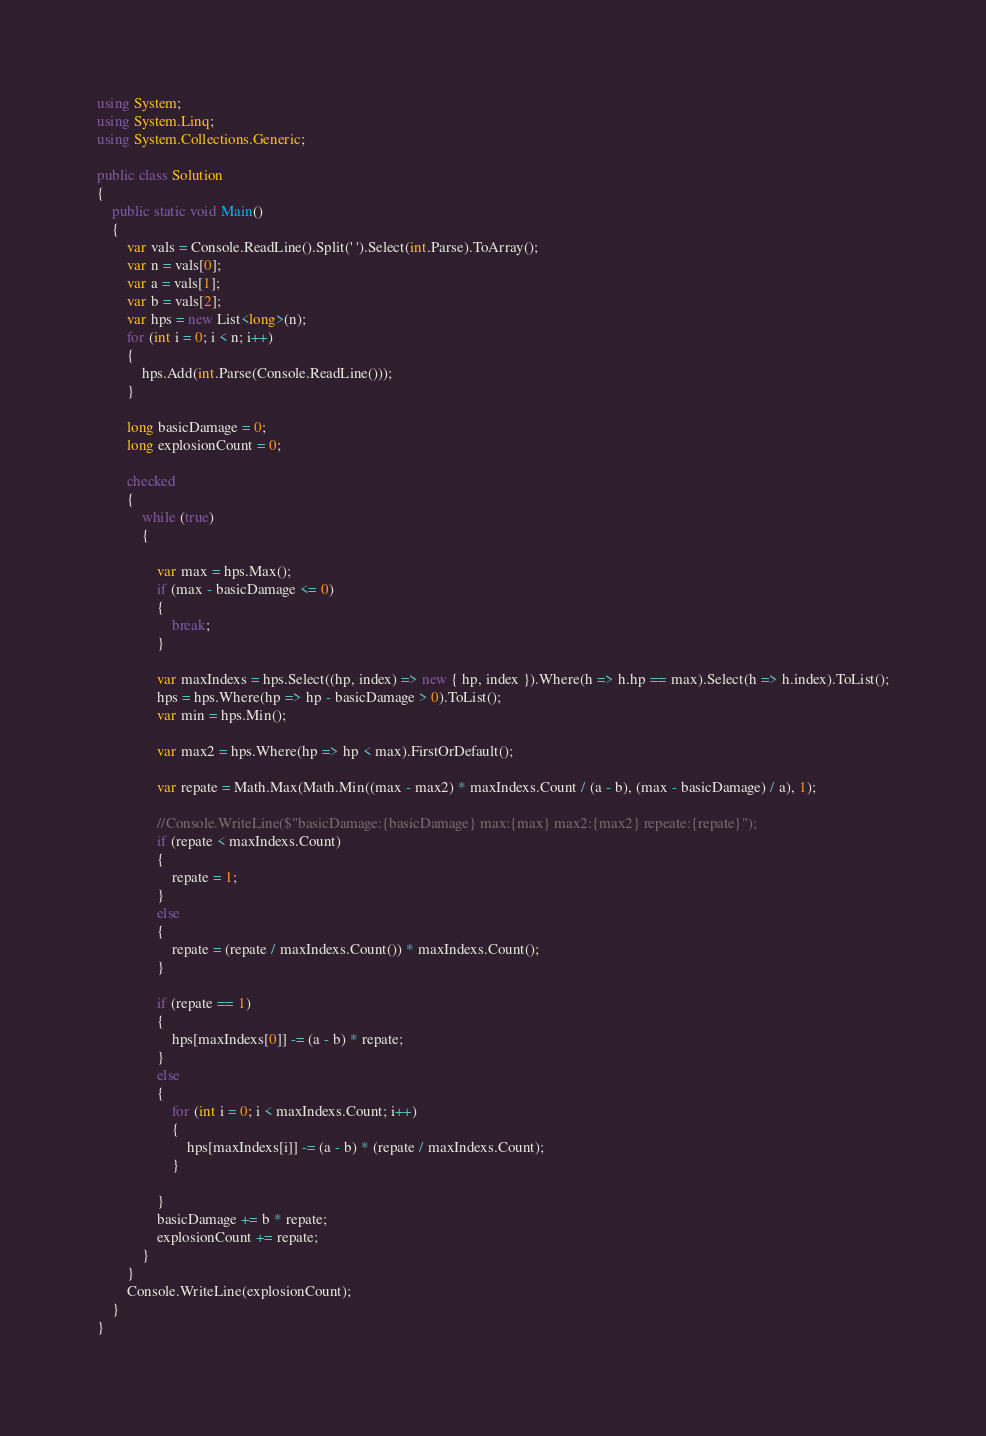Convert code to text. <code><loc_0><loc_0><loc_500><loc_500><_C#_>using System;
using System.Linq;
using System.Collections.Generic;

public class Solution
{
    public static void Main()
    {
        var vals = Console.ReadLine().Split(' ').Select(int.Parse).ToArray();
        var n = vals[0];
        var a = vals[1];
        var b = vals[2];
        var hps = new List<long>(n);
        for (int i = 0; i < n; i++)
        {
            hps.Add(int.Parse(Console.ReadLine()));
        }

        long basicDamage = 0;
        long explosionCount = 0;

        checked
        {
            while (true)
            {

                var max = hps.Max();
                if (max - basicDamage <= 0)
                {
                    break;
                }

                var maxIndexs = hps.Select((hp, index) => new { hp, index }).Where(h => h.hp == max).Select(h => h.index).ToList();
                hps = hps.Where(hp => hp - basicDamage > 0).ToList();
                var min = hps.Min();

                var max2 = hps.Where(hp => hp < max).FirstOrDefault();

                var repate = Math.Max(Math.Min((max - max2) * maxIndexs.Count / (a - b), (max - basicDamage) / a), 1);

                //Console.WriteLine($"basicDamage:{basicDamage} max:{max} max2:{max2} repeate:{repate}");
                if (repate < maxIndexs.Count)
                {
                    repate = 1;
                }
                else
                {
                    repate = (repate / maxIndexs.Count()) * maxIndexs.Count();
                }

                if (repate == 1)
                {
                    hps[maxIndexs[0]] -= (a - b) * repate;
                }
                else
                {
                    for (int i = 0; i < maxIndexs.Count; i++)
                    {
                        hps[maxIndexs[i]] -= (a - b) * (repate / maxIndexs.Count);
                    }

                }
                basicDamage += b * repate;
                explosionCount += repate;
            }
        }
        Console.WriteLine(explosionCount);
    }
}</code> 